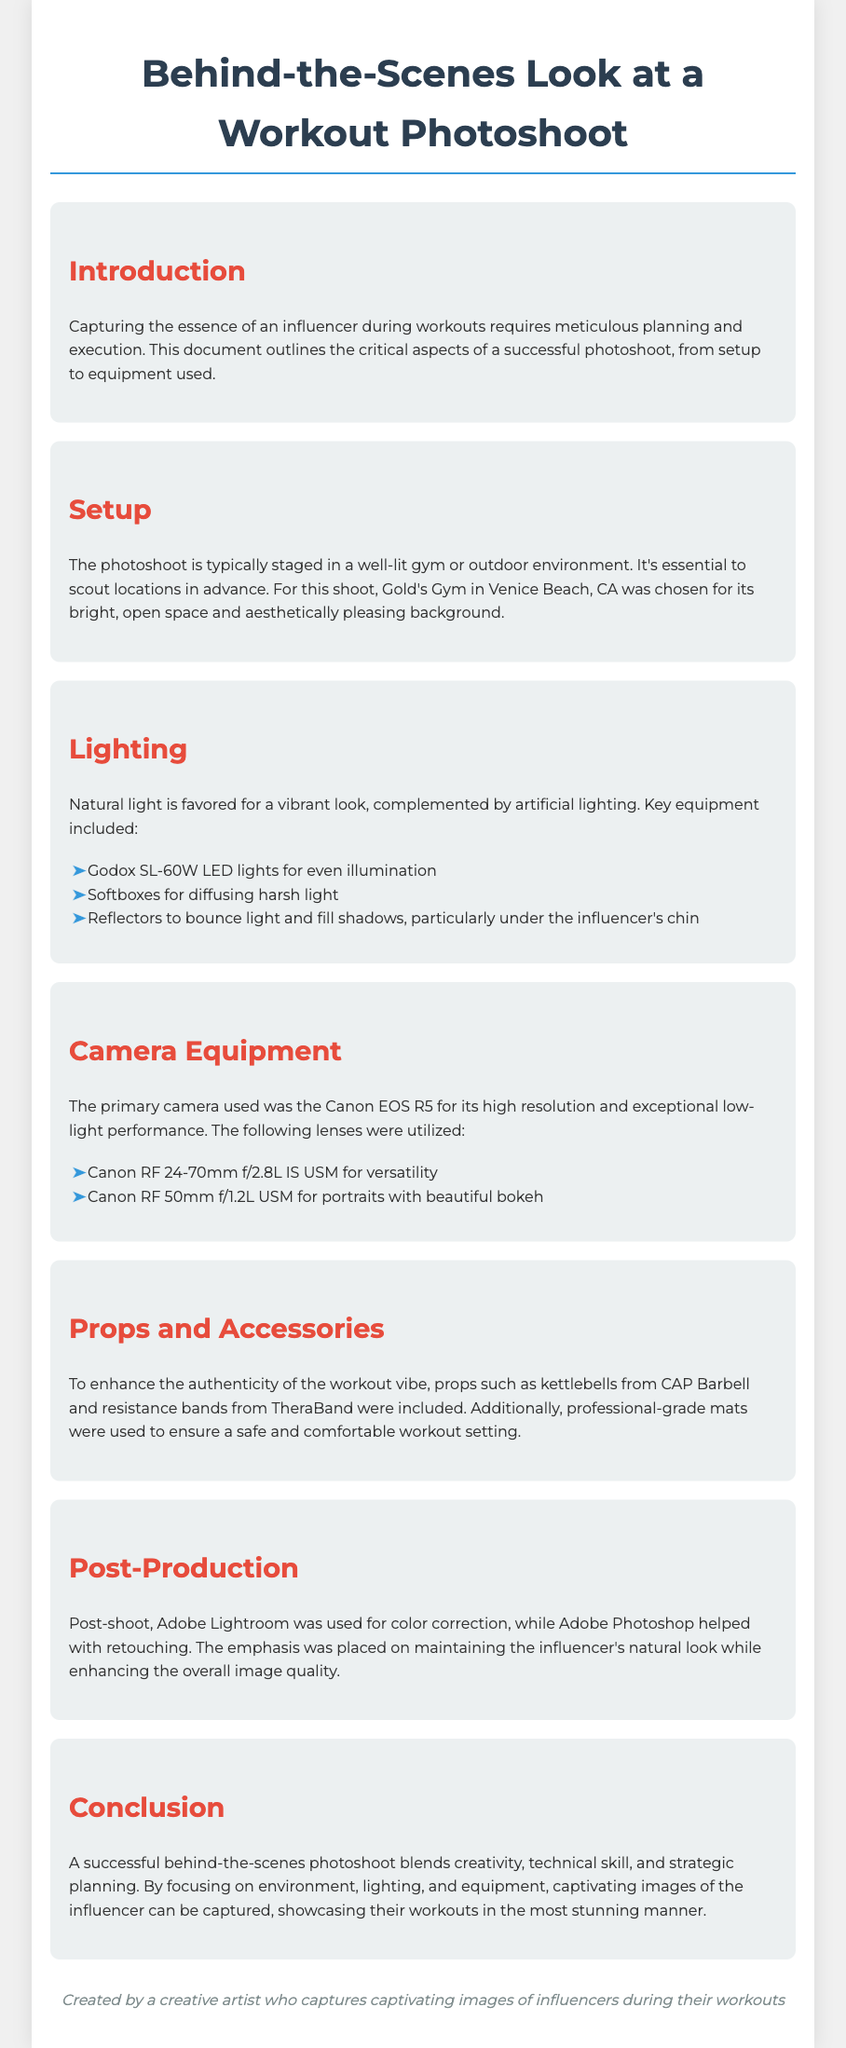What location was chosen for the photoshoot? The location is important as it affects the overall aesthetic, and the document states that Gold's Gym in Venice Beach, CA was chosen.
Answer: Gold's Gym in Venice Beach, CA What lighting equipment was primarily used? The document lists Godox SL-60W LED lights as key lighting equipment, indicating its importance for even illumination.
Answer: Godox SL-60W LED lights What camera was used for the photoshoot? The document specifies that the Canon EOS R5 was the primary camera used for its high resolution and low-light performance.
Answer: Canon EOS R5 Which lens was used for portraits? The document highlights the Canon RF 50mm f/1.2L USM lens used for portraits with beautiful bokeh, showcasing the specific type of photography focus.
Answer: Canon RF 50mm f/1.2L USM What software was used for post-shoot color correction? The document mentions Adobe Lightroom as the software used for color correction, indicating its role in post-production.
Answer: Adobe Lightroom What is the main focus of the photoshoot? The primary aim of the photoshoot is to capture stunning images of the influencer during workouts, highlighting the specific intention of the project.
Answer: Capturing stunning images of the influencer during workouts Why is natural light favored in the photoshoot? The document states that natural light is favored for a vibrant look, offering reasoning for the choice of lighting in the setup.
Answer: For a vibrant look What was used to diffuse harsh light? Softboxes were mentioned as the tool used to diffuse harsh light, indicating the effort to manage lighting conditions.
Answer: Softboxes 